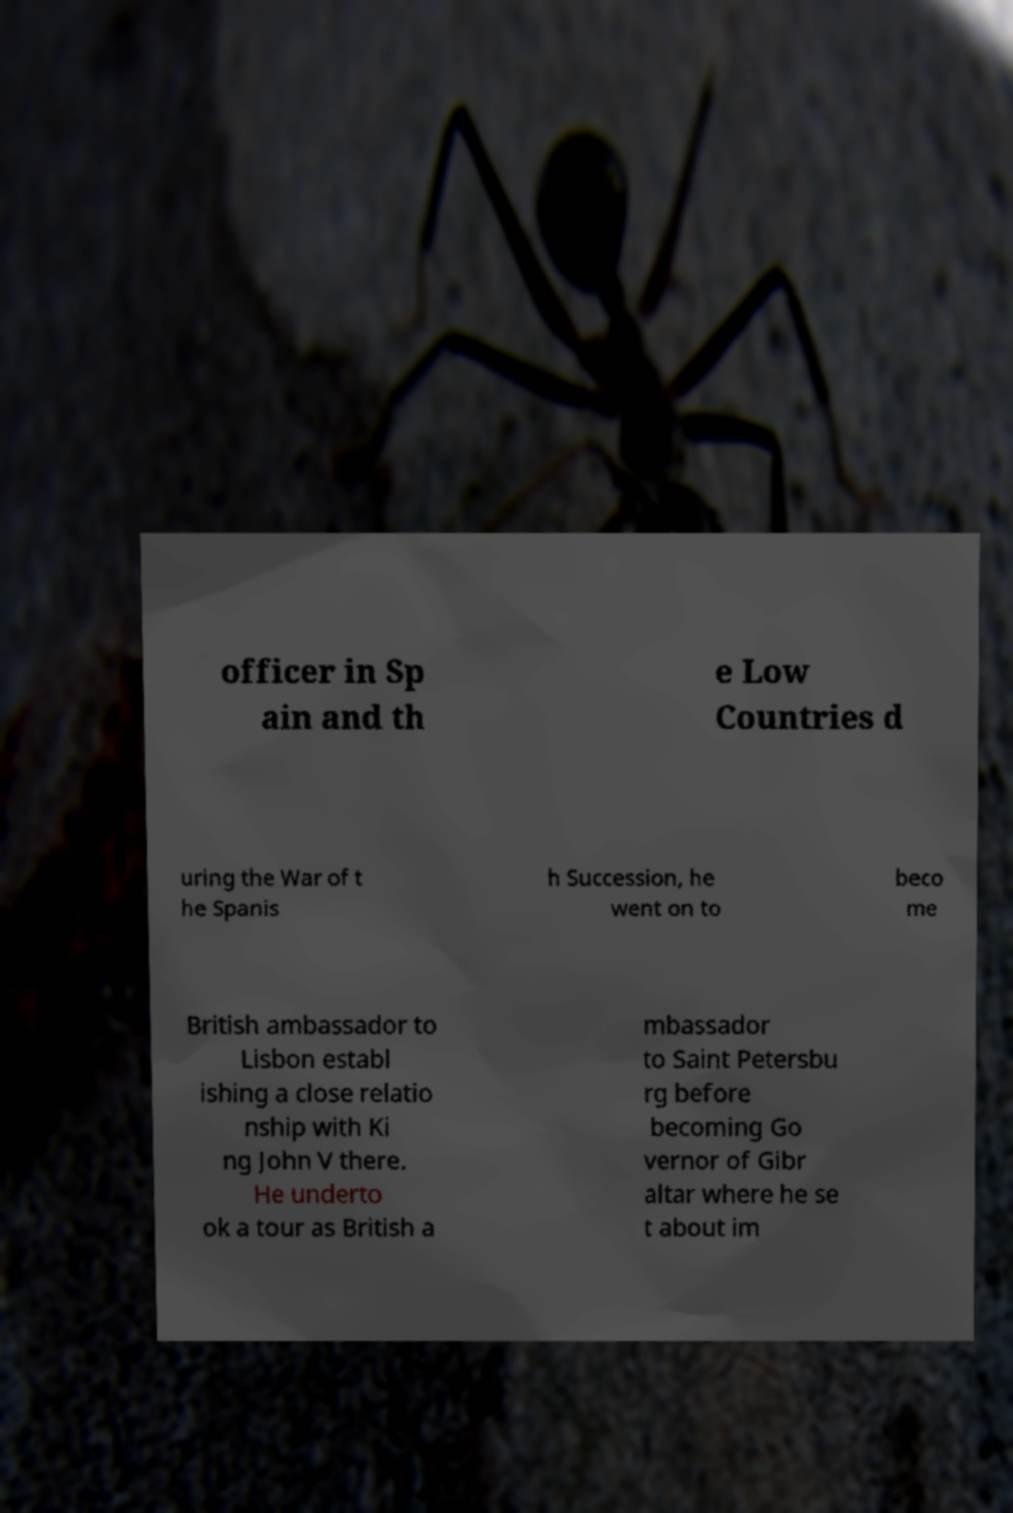Can you read and provide the text displayed in the image?This photo seems to have some interesting text. Can you extract and type it out for me? officer in Sp ain and th e Low Countries d uring the War of t he Spanis h Succession, he went on to beco me British ambassador to Lisbon establ ishing a close relatio nship with Ki ng John V there. He underto ok a tour as British a mbassador to Saint Petersbu rg before becoming Go vernor of Gibr altar where he se t about im 